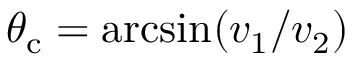Convert formula to latex. <formula><loc_0><loc_0><loc_500><loc_500>\theta _ { c } = \arcsin ( v _ { 1 } / v _ { 2 } )</formula> 